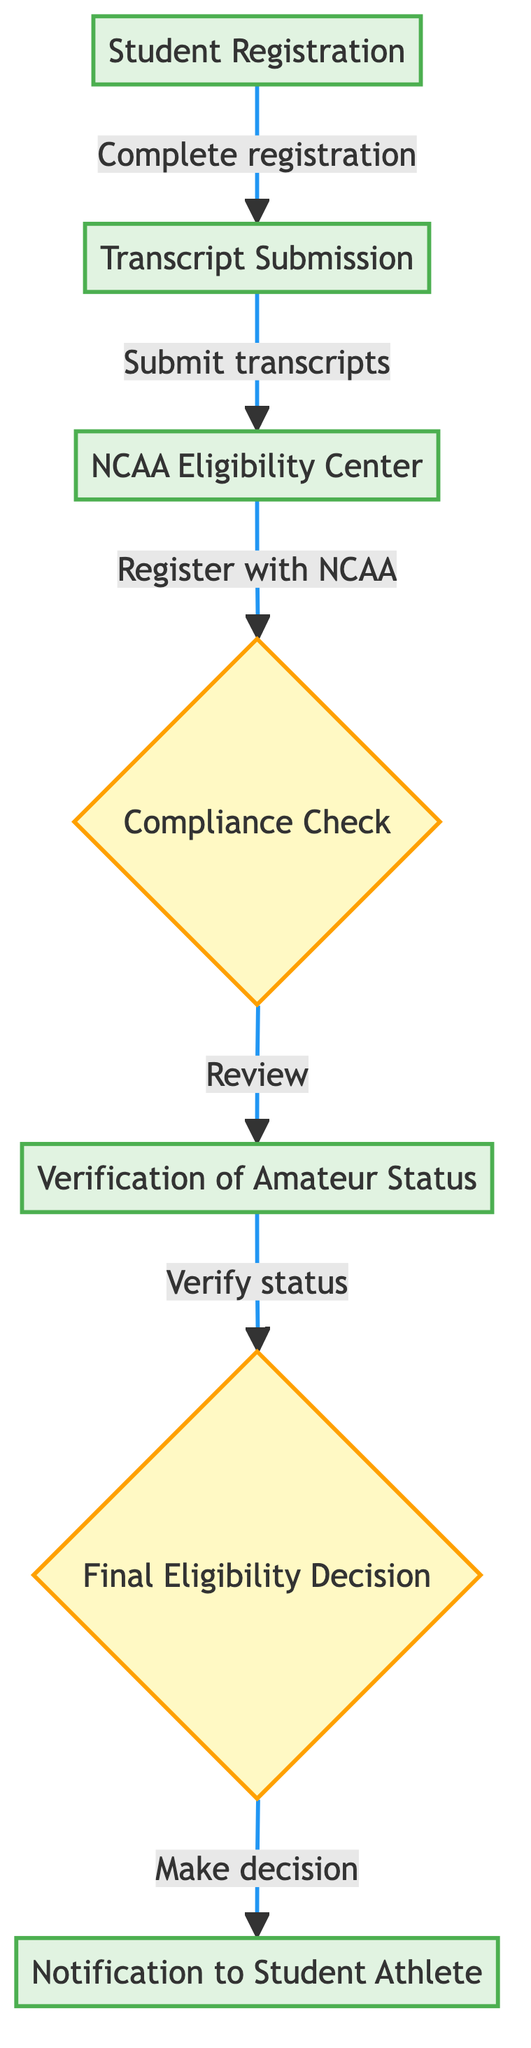what is the first step in the eligibility verification process? The first step listed in the flow chart is "Student Registration", indicating that students must complete their registration as the initial action.
Answer: Student Registration how many processes are there in the diagram? By counting the labeled nodes that indicate actions or processes, there are five processes: Student Registration, Transcript Submission, NCAA Eligibility Center, Verification of Amateur Status, and Notification to Student Athlete.
Answer: Five what does the compliance office do after reviewing transcripts? After reviewing transcripts during the Compliance Check, the compliance office proceeds to verify the amateur status of the student athlete as the next step in the process.
Answer: Verify status which step follows the transcript submission? The step that follows "Transcript Submission" is "NCAA Eligibility Center", where students must register with the NCAA for eligibility certification.
Answer: NCAA Eligibility Center what happens after the final eligibility decision? Following the "Final Eligibility Decision", students receive a "Notification to Student Athlete" about their eligibility status and any required next steps.
Answer: Notification to Student Athlete how many decision nodes are in the flow chart? The flow chart contains two decision nodes: "Compliance Check" and "Final Eligibility Decision". These nodes indicate points where evaluations and rulings are made concerning eligibility.
Answer: Two who is responsible for the final eligibility decision? The compliance office is responsible for making the "Final Eligibility Decision" based on the gathered information during the process.
Answer: Compliance office where does the process start? The process starts at the "Student Registration" step, where students begin by completing their registration.
Answer: Student Registration what is the last action in the eligibility verification process? The last action in the eligibility verification process is "Notification to Student Athlete," where the students are informed about their eligibility status.
Answer: Notification to Student Athlete 